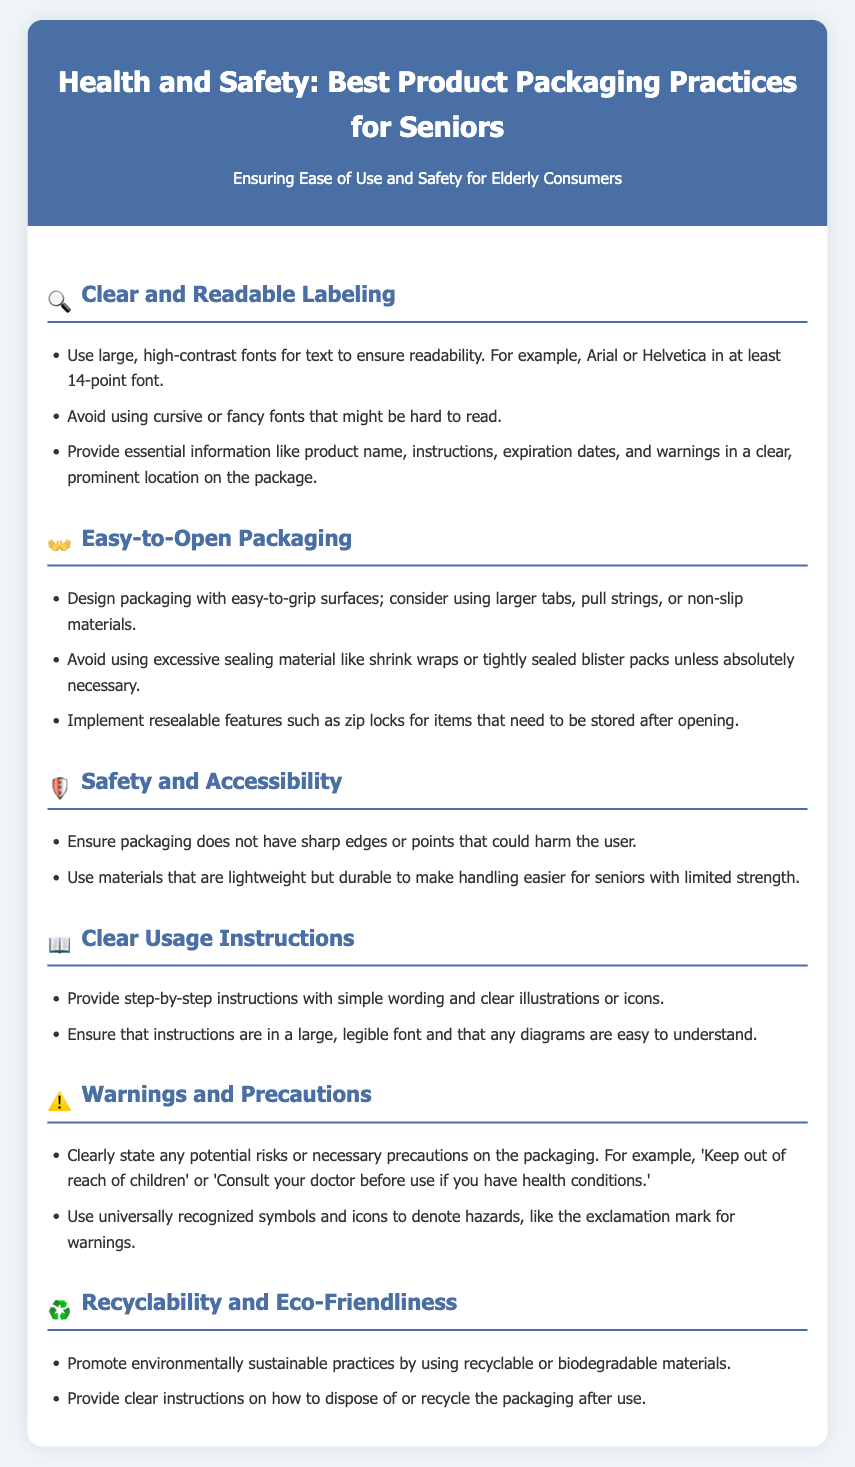What is the font size recommended for labeling? The recommended font size for labeling is at least 14-point font.
Answer: 14-point What should you avoid using for font types? The document suggests avoiding cursive or fancy fonts that might be hard to read.
Answer: Cursive or fancy fonts What packaging feature can help with easy opening? The document states that packaging should have easy-to-grip surfaces for better accessibility.
Answer: Easy-to-grip surfaces What is an essential safety consideration mentioned? The document mentions that packaging should not have sharp edges or points that could harm the user.
Answer: Sharp edges What type of instructions should be provided? Step-by-step instructions with simple wording and clear illustrations or icons should be provided.
Answer: Step-by-step instructions Which symbol is mentioned for warning hazards? The document suggests using universally recognized symbols like the exclamation mark for warnings.
Answer: Exclamation mark What material types are encouraged for packaging? The document encourages the use of recyclable or biodegradable materials.
Answer: Recyclable or biodegradable materials 